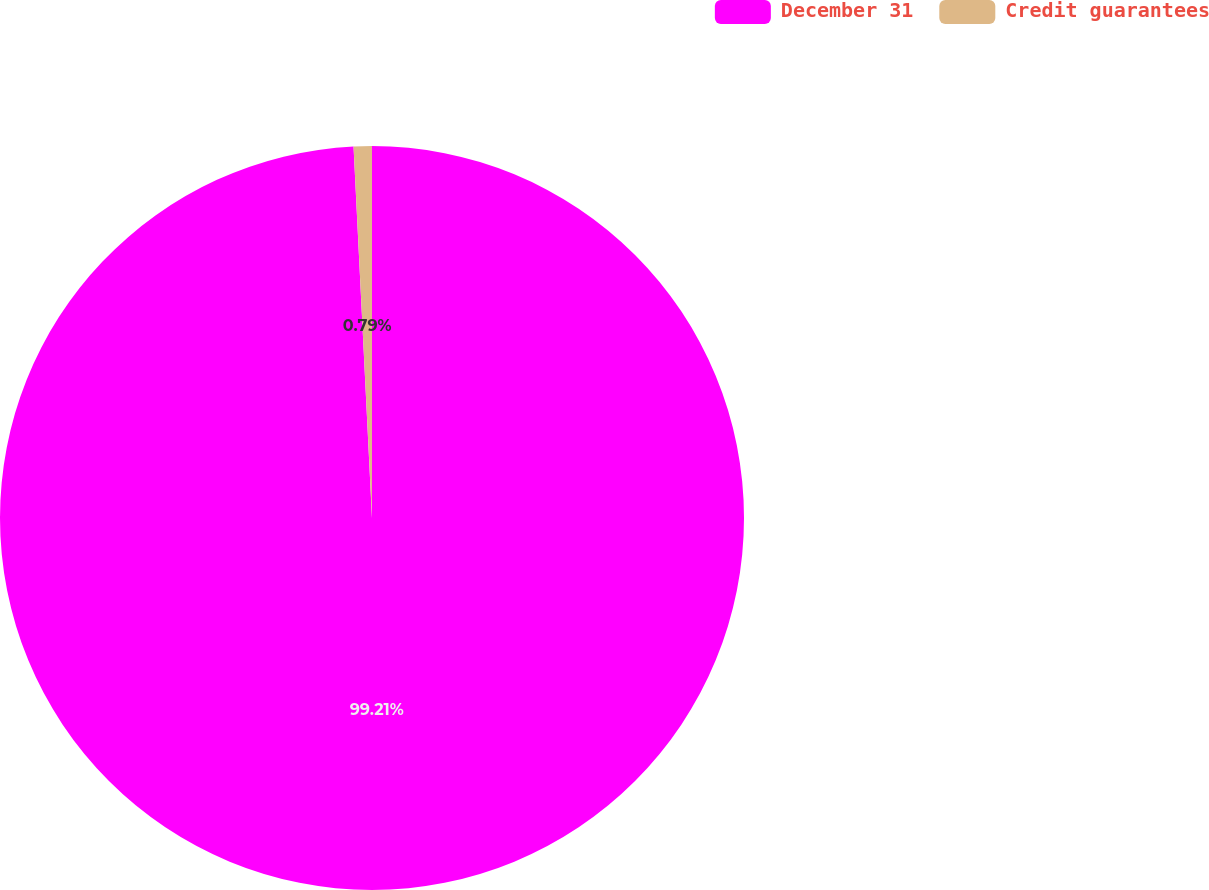<chart> <loc_0><loc_0><loc_500><loc_500><pie_chart><fcel>December 31<fcel>Credit guarantees<nl><fcel>99.21%<fcel>0.79%<nl></chart> 